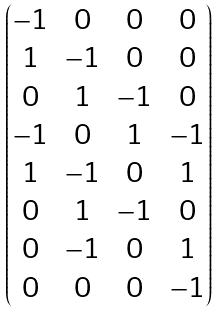<formula> <loc_0><loc_0><loc_500><loc_500>\begin{pmatrix} - 1 & 0 & 0 & 0 \\ 1 & - 1 & 0 & 0 \\ 0 & 1 & - 1 & 0 \\ - 1 & 0 & 1 & - 1 \\ 1 & - 1 & 0 & 1 \\ 0 & 1 & - 1 & 0 \\ 0 & - 1 & 0 & 1 \\ 0 & 0 & 0 & - 1 \end{pmatrix}</formula> 